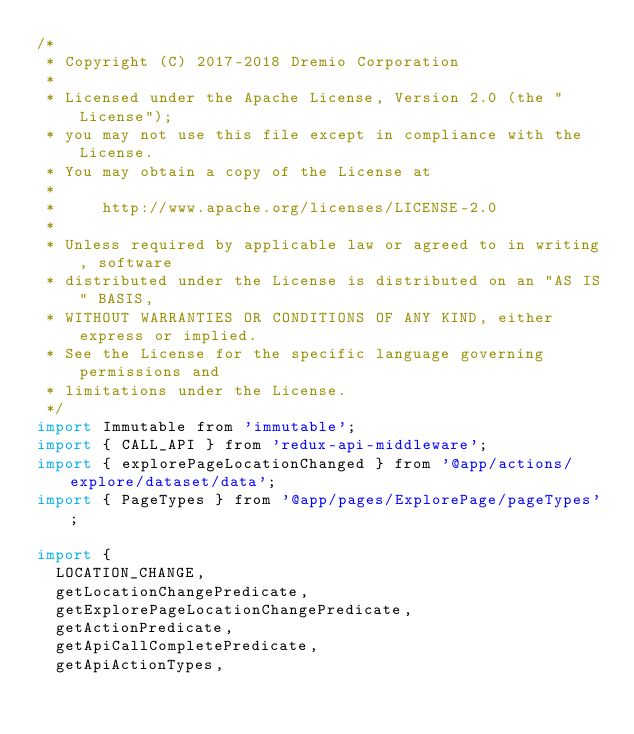Convert code to text. <code><loc_0><loc_0><loc_500><loc_500><_JavaScript_>/*
 * Copyright (C) 2017-2018 Dremio Corporation
 *
 * Licensed under the Apache License, Version 2.0 (the "License");
 * you may not use this file except in compliance with the License.
 * You may obtain a copy of the License at
 *
 *     http://www.apache.org/licenses/LICENSE-2.0
 *
 * Unless required by applicable law or agreed to in writing, software
 * distributed under the License is distributed on an "AS IS" BASIS,
 * WITHOUT WARRANTIES OR CONDITIONS OF ANY KIND, either express or implied.
 * See the License for the specific language governing permissions and
 * limitations under the License.
 */
import Immutable from 'immutable';
import { CALL_API } from 'redux-api-middleware';
import { explorePageLocationChanged } from '@app/actions/explore/dataset/data';
import { PageTypes } from '@app/pages/ExplorePage/pageTypes';

import {
  LOCATION_CHANGE,
  getLocationChangePredicate,
  getExplorePageLocationChangePredicate,
  getActionPredicate,
  getApiCallCompletePredicate,
  getApiActionTypes,</code> 